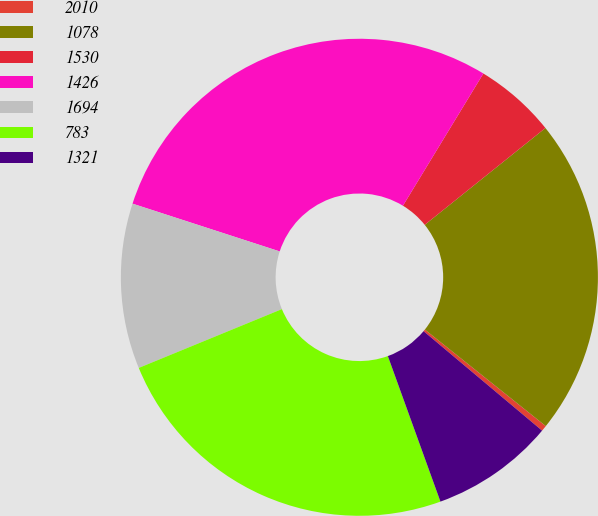Convert chart to OTSL. <chart><loc_0><loc_0><loc_500><loc_500><pie_chart><fcel>2010<fcel>1078<fcel>1530<fcel>1426<fcel>1694<fcel>783<fcel>1321<nl><fcel>0.39%<fcel>21.49%<fcel>5.54%<fcel>28.71%<fcel>11.2%<fcel>24.32%<fcel>8.37%<nl></chart> 